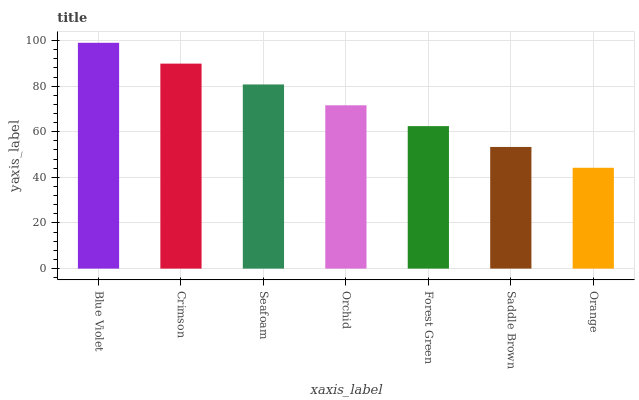Is Orange the minimum?
Answer yes or no. Yes. Is Blue Violet the maximum?
Answer yes or no. Yes. Is Crimson the minimum?
Answer yes or no. No. Is Crimson the maximum?
Answer yes or no. No. Is Blue Violet greater than Crimson?
Answer yes or no. Yes. Is Crimson less than Blue Violet?
Answer yes or no. Yes. Is Crimson greater than Blue Violet?
Answer yes or no. No. Is Blue Violet less than Crimson?
Answer yes or no. No. Is Orchid the high median?
Answer yes or no. Yes. Is Orchid the low median?
Answer yes or no. Yes. Is Blue Violet the high median?
Answer yes or no. No. Is Crimson the low median?
Answer yes or no. No. 